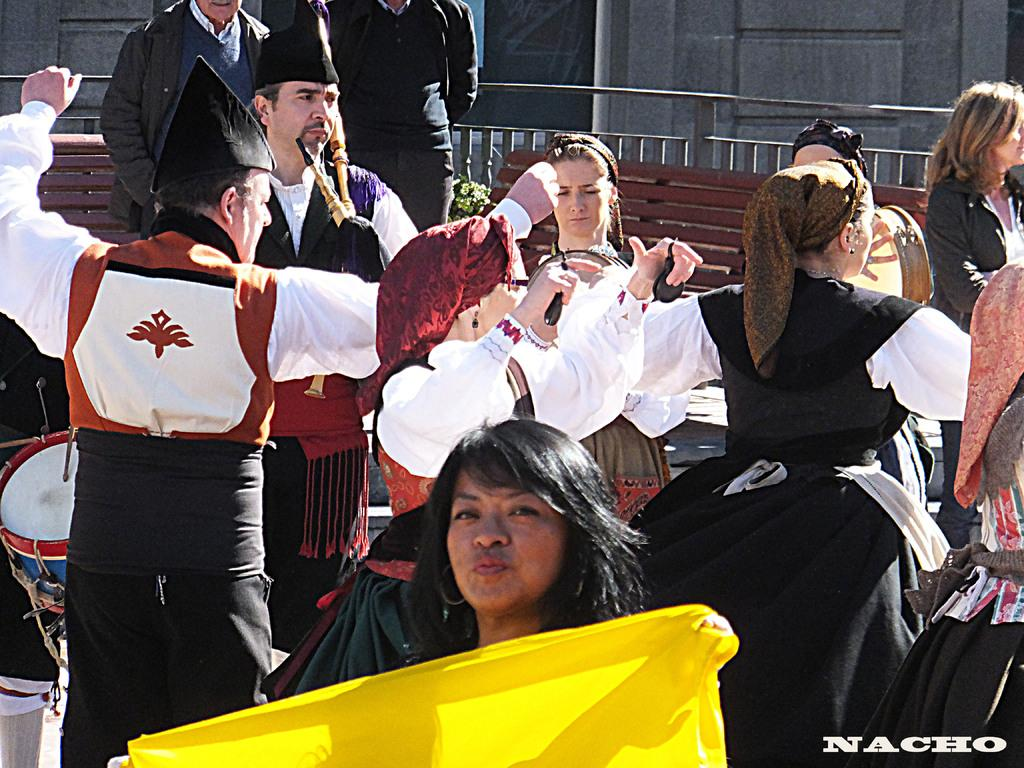What are the people in the image doing? The people in the image are dancing in the center of the image. What can be seen in the background of the image? There is a railing and benches in the background of the image. What type of drain can be seen in the image? There is no drain present in the image. What things are being jammed together in the image? There are no things being jammed together in the image; people are dancing and there are benches and a railing in the background. 